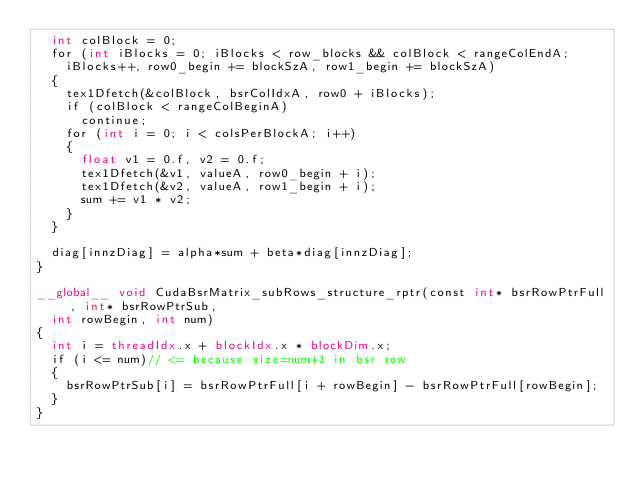<code> <loc_0><loc_0><loc_500><loc_500><_Cuda_>	int colBlock = 0;
	for (int iBlocks = 0; iBlocks < row_blocks && colBlock < rangeColEndA; 
		iBlocks++, row0_begin += blockSzA, row1_begin += blockSzA)
	{
		tex1Dfetch(&colBlock, bsrColIdxA, row0 + iBlocks);
		if (colBlock < rangeColBeginA)
			continue;
		for (int i = 0; i < colsPerBlockA; i++)
		{
			float v1 = 0.f, v2 = 0.f;
			tex1Dfetch(&v1, valueA, row0_begin + i);
			tex1Dfetch(&v2, valueA, row1_begin + i);
			sum += v1 * v2;
		}
	}

	diag[innzDiag] = alpha*sum + beta*diag[innzDiag];
}

__global__ void CudaBsrMatrix_subRows_structure_rptr(const int* bsrRowPtrFull, int* bsrRowPtrSub,
	int rowBegin, int num)
{
	int i = threadIdx.x + blockIdx.x * blockDim.x;
	if (i <= num)// <= because size=num+1 in bsr row
	{
		bsrRowPtrSub[i] = bsrRowPtrFull[i + rowBegin] - bsrRowPtrFull[rowBegin];
	}
}
</code> 